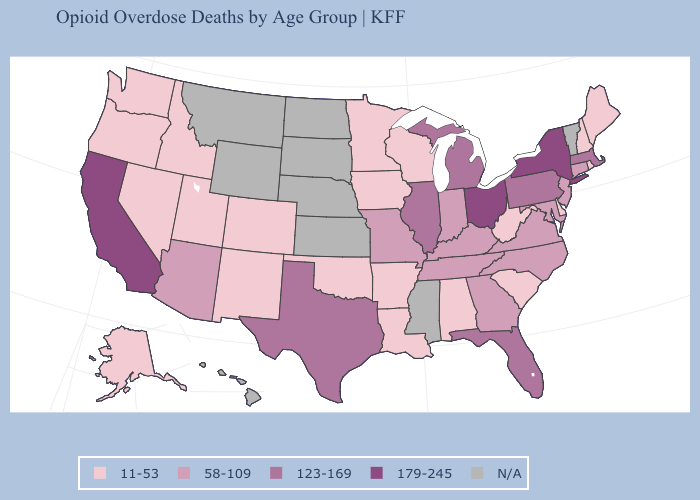Does Ohio have the highest value in the USA?
Keep it brief. Yes. What is the lowest value in the USA?
Short answer required. 11-53. Which states have the lowest value in the USA?
Concise answer only. Alabama, Alaska, Arkansas, Colorado, Delaware, Idaho, Iowa, Louisiana, Maine, Minnesota, Nevada, New Hampshire, New Mexico, Oklahoma, Oregon, Rhode Island, South Carolina, Utah, Washington, West Virginia, Wisconsin. What is the value of Texas?
Short answer required. 123-169. Name the states that have a value in the range N/A?
Be succinct. Hawaii, Kansas, Mississippi, Montana, Nebraska, North Dakota, South Dakota, Vermont, Wyoming. What is the value of South Dakota?
Short answer required. N/A. Among the states that border Kentucky , does Missouri have the highest value?
Be succinct. No. Which states hav the highest value in the South?
Give a very brief answer. Florida, Texas. Does Florida have the lowest value in the USA?
Answer briefly. No. What is the value of Montana?
Keep it brief. N/A. Among the states that border Nebraska , does Iowa have the highest value?
Concise answer only. No. Name the states that have a value in the range 179-245?
Short answer required. California, New York, Ohio. Name the states that have a value in the range N/A?
Keep it brief. Hawaii, Kansas, Mississippi, Montana, Nebraska, North Dakota, South Dakota, Vermont, Wyoming. 